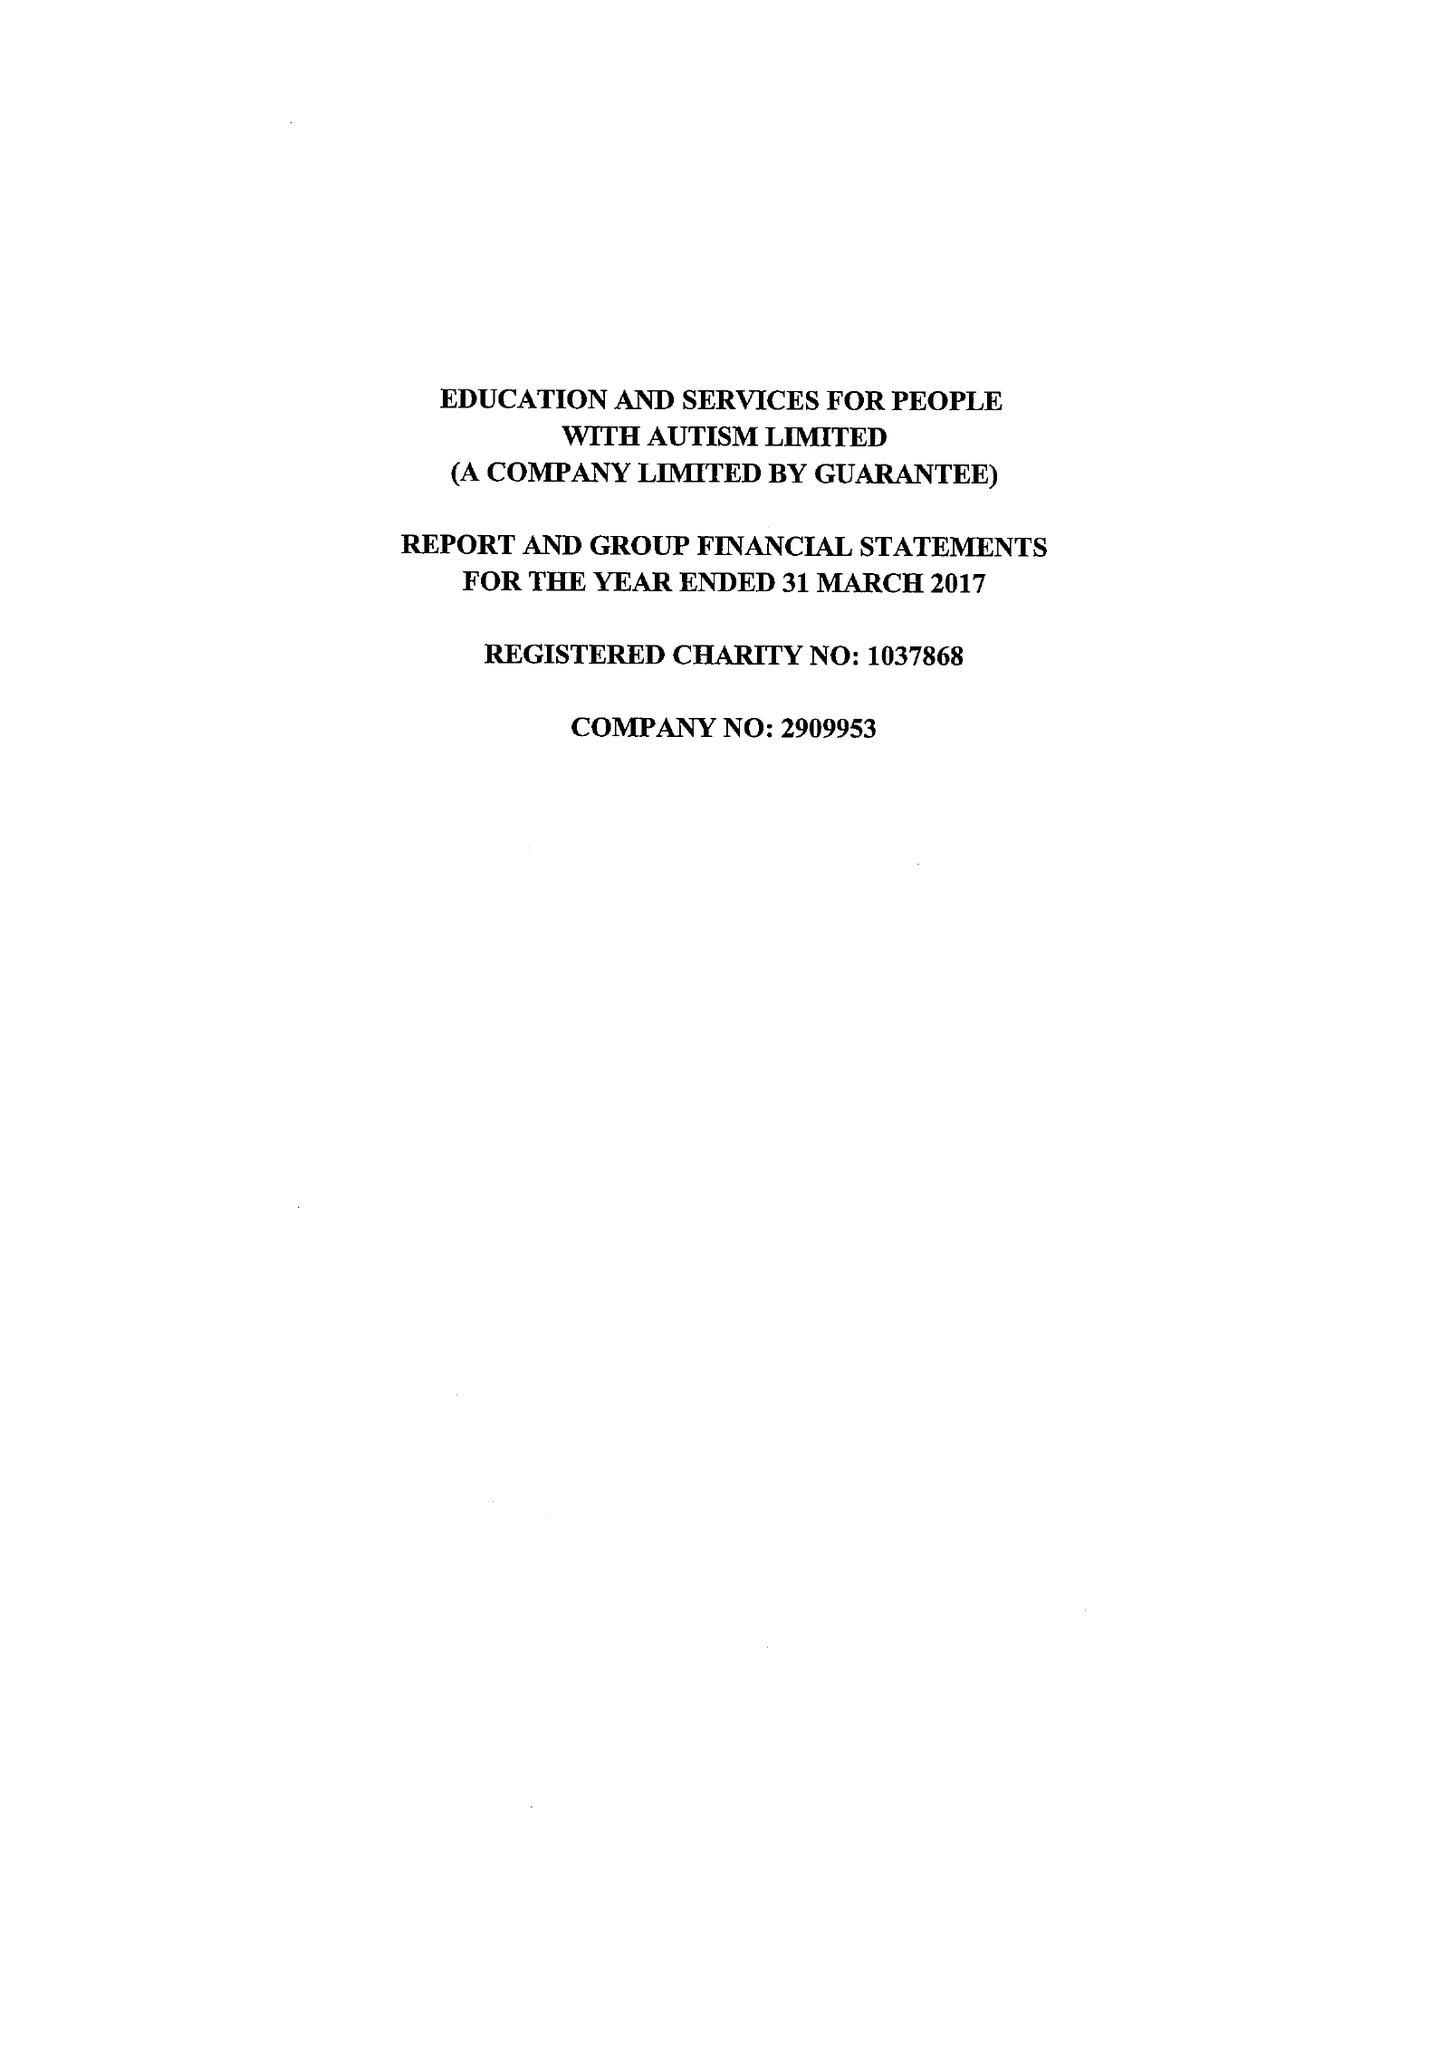What is the value for the income_annually_in_british_pounds?
Answer the question using a single word or phrase. 13750718.00 